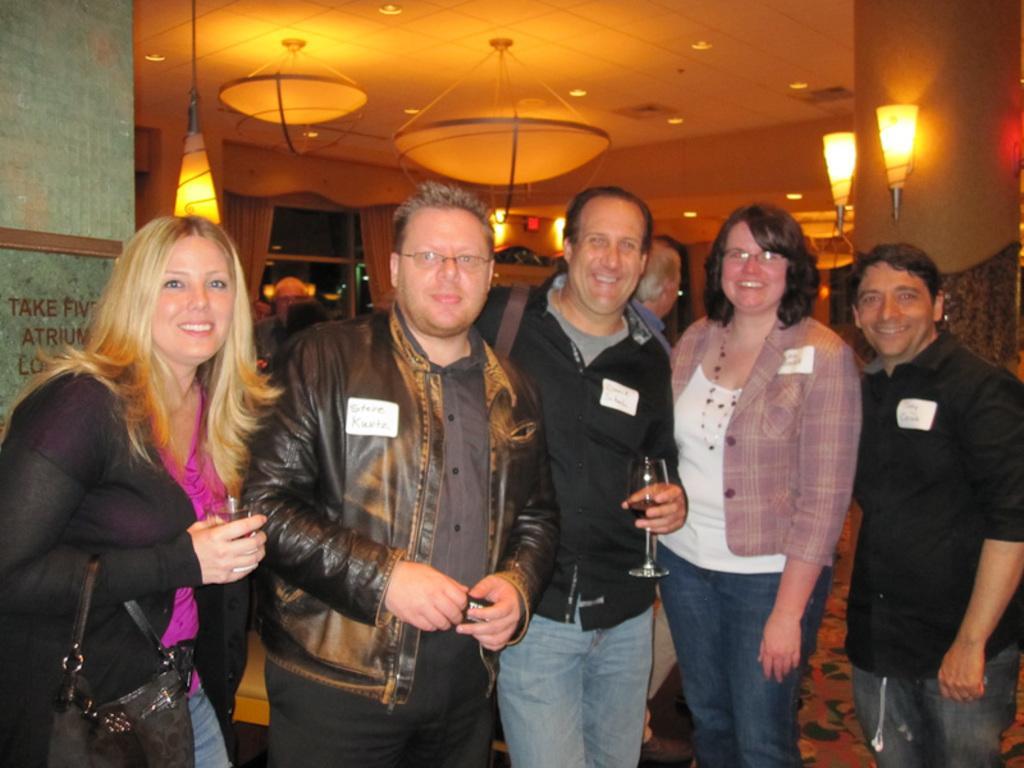How would you summarize this image in a sentence or two? In this picture I can see there are five people standing here and the woman on to left is holding a wine glass and the person standing at the center is wearing a black shirt and holding a wine glass. In the backdrop there are some other people and there are lights attached to the wall. 